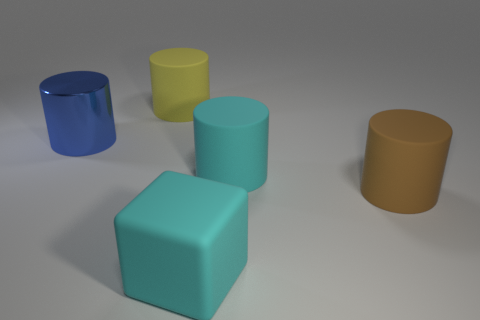How many cylinders have the same color as the large block?
Provide a short and direct response. 1. What size is the blue thing?
Make the answer very short. Large. Is the blue metal cylinder the same size as the cyan rubber block?
Your answer should be very brief. Yes. What is the color of the large rubber thing that is both on the left side of the big cyan cylinder and in front of the large blue object?
Provide a succinct answer. Cyan. How many yellow objects have the same material as the big block?
Your response must be concise. 1. What number of tiny blue rubber blocks are there?
Your response must be concise. 0. Is the size of the cyan cube the same as the cylinder to the left of the yellow matte cylinder?
Provide a succinct answer. Yes. There is a cylinder that is to the right of the large cyan thing that is behind the matte cube; what is it made of?
Your response must be concise. Rubber. There is a rubber object behind the cylinder that is to the left of the big cylinder behind the large blue object; how big is it?
Offer a very short reply. Large. Is the shape of the large blue shiny thing the same as the object behind the blue metal thing?
Provide a succinct answer. Yes. 